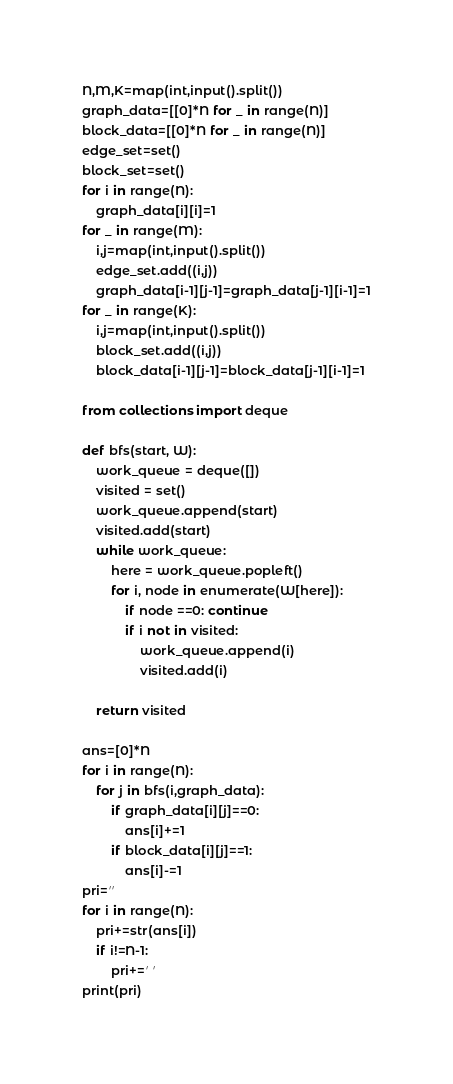<code> <loc_0><loc_0><loc_500><loc_500><_Python_>N,M,K=map(int,input().split())
graph_data=[[0]*N for _ in range(N)]
block_data=[[0]*N for _ in range(N)]
edge_set=set()
block_set=set()
for i in range(N):
    graph_data[i][i]=1
for _ in range(M):
    i,j=map(int,input().split())
    edge_set.add((i,j))
    graph_data[i-1][j-1]=graph_data[j-1][i-1]=1
for _ in range(K):
    i,j=map(int,input().split())
    block_set.add((i,j))
    block_data[i-1][j-1]=block_data[j-1][i-1]=1

from collections import deque

def bfs(start, W):
    work_queue = deque([])
    visited = set()
    work_queue.append(start)
    visited.add(start)
    while work_queue:
        here = work_queue.popleft()
        for i, node in enumerate(W[here]):
            if node ==0: continue
            if i not in visited:
                work_queue.append(i)
                visited.add(i)

    return visited

ans=[0]*N
for i in range(N):
    for j in bfs(i,graph_data):
        if graph_data[i][j]==0:
            ans[i]+=1
        if block_data[i][j]==1:
            ans[i]-=1
pri=''
for i in range(N):
    pri+=str(ans[i])
    if i!=N-1:
        pri+=' '
print(pri)</code> 